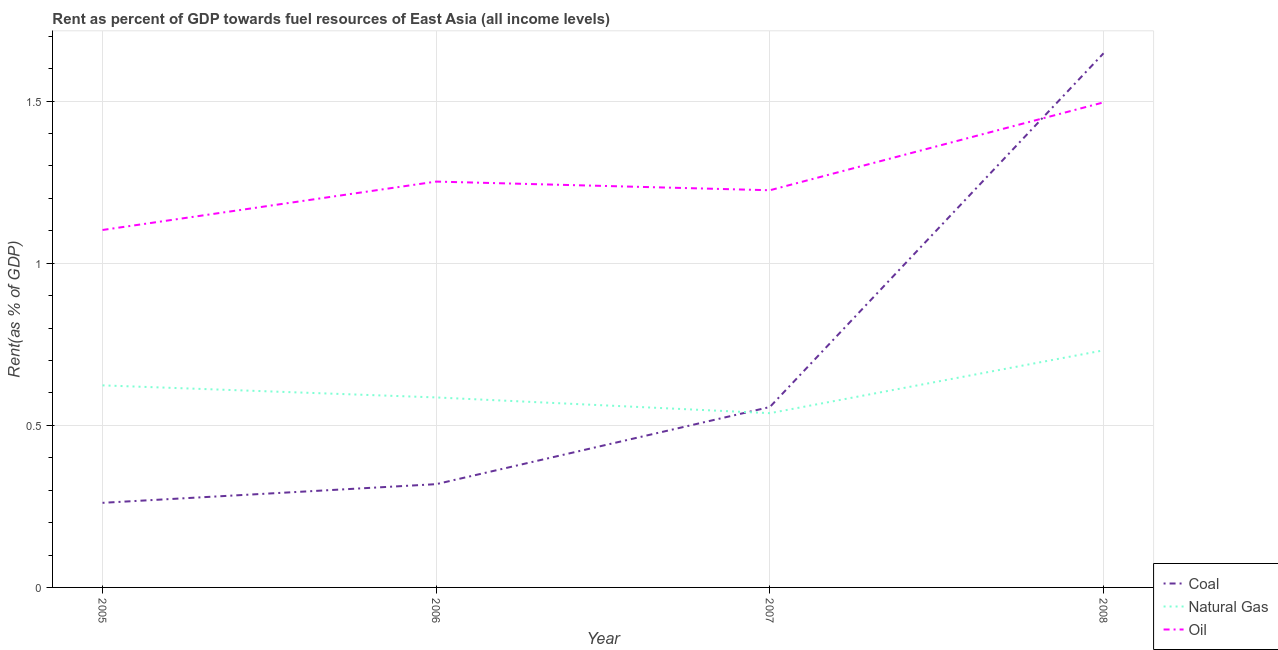How many different coloured lines are there?
Ensure brevity in your answer.  3. Does the line corresponding to rent towards coal intersect with the line corresponding to rent towards natural gas?
Your answer should be compact. Yes. Is the number of lines equal to the number of legend labels?
Offer a very short reply. Yes. What is the rent towards natural gas in 2008?
Give a very brief answer. 0.73. Across all years, what is the maximum rent towards coal?
Ensure brevity in your answer.  1.65. Across all years, what is the minimum rent towards coal?
Give a very brief answer. 0.26. In which year was the rent towards natural gas maximum?
Offer a very short reply. 2008. What is the total rent towards coal in the graph?
Your answer should be very brief. 2.78. What is the difference between the rent towards natural gas in 2005 and that in 2006?
Your response must be concise. 0.04. What is the difference between the rent towards coal in 2008 and the rent towards natural gas in 2006?
Offer a very short reply. 1.06. What is the average rent towards natural gas per year?
Ensure brevity in your answer.  0.62. In the year 2007, what is the difference between the rent towards natural gas and rent towards coal?
Keep it short and to the point. -0.02. In how many years, is the rent towards oil greater than 1.5 %?
Offer a terse response. 0. What is the ratio of the rent towards oil in 2005 to that in 2008?
Provide a succinct answer. 0.74. Is the difference between the rent towards coal in 2005 and 2008 greater than the difference between the rent towards natural gas in 2005 and 2008?
Your answer should be compact. No. What is the difference between the highest and the second highest rent towards oil?
Offer a terse response. 0.24. What is the difference between the highest and the lowest rent towards natural gas?
Ensure brevity in your answer.  0.19. In how many years, is the rent towards coal greater than the average rent towards coal taken over all years?
Ensure brevity in your answer.  1. Is the sum of the rent towards oil in 2005 and 2007 greater than the maximum rent towards coal across all years?
Keep it short and to the point. Yes. Is it the case that in every year, the sum of the rent towards coal and rent towards natural gas is greater than the rent towards oil?
Your answer should be very brief. No. Is the rent towards natural gas strictly greater than the rent towards coal over the years?
Ensure brevity in your answer.  No. Are the values on the major ticks of Y-axis written in scientific E-notation?
Offer a very short reply. No. Does the graph contain grids?
Keep it short and to the point. Yes. What is the title of the graph?
Your response must be concise. Rent as percent of GDP towards fuel resources of East Asia (all income levels). What is the label or title of the X-axis?
Ensure brevity in your answer.  Year. What is the label or title of the Y-axis?
Give a very brief answer. Rent(as % of GDP). What is the Rent(as % of GDP) of Coal in 2005?
Your response must be concise. 0.26. What is the Rent(as % of GDP) in Natural Gas in 2005?
Your answer should be very brief. 0.62. What is the Rent(as % of GDP) in Oil in 2005?
Provide a short and direct response. 1.1. What is the Rent(as % of GDP) in Coal in 2006?
Offer a terse response. 0.32. What is the Rent(as % of GDP) of Natural Gas in 2006?
Provide a succinct answer. 0.59. What is the Rent(as % of GDP) of Oil in 2006?
Provide a succinct answer. 1.25. What is the Rent(as % of GDP) in Coal in 2007?
Provide a short and direct response. 0.56. What is the Rent(as % of GDP) of Natural Gas in 2007?
Ensure brevity in your answer.  0.54. What is the Rent(as % of GDP) in Oil in 2007?
Offer a very short reply. 1.22. What is the Rent(as % of GDP) in Coal in 2008?
Provide a succinct answer. 1.65. What is the Rent(as % of GDP) of Natural Gas in 2008?
Provide a short and direct response. 0.73. What is the Rent(as % of GDP) of Oil in 2008?
Your answer should be very brief. 1.5. Across all years, what is the maximum Rent(as % of GDP) in Coal?
Offer a terse response. 1.65. Across all years, what is the maximum Rent(as % of GDP) of Natural Gas?
Keep it short and to the point. 0.73. Across all years, what is the maximum Rent(as % of GDP) of Oil?
Your answer should be very brief. 1.5. Across all years, what is the minimum Rent(as % of GDP) of Coal?
Your answer should be compact. 0.26. Across all years, what is the minimum Rent(as % of GDP) of Natural Gas?
Give a very brief answer. 0.54. Across all years, what is the minimum Rent(as % of GDP) of Oil?
Give a very brief answer. 1.1. What is the total Rent(as % of GDP) in Coal in the graph?
Ensure brevity in your answer.  2.78. What is the total Rent(as % of GDP) of Natural Gas in the graph?
Give a very brief answer. 2.48. What is the total Rent(as % of GDP) in Oil in the graph?
Give a very brief answer. 5.07. What is the difference between the Rent(as % of GDP) in Coal in 2005 and that in 2006?
Provide a short and direct response. -0.06. What is the difference between the Rent(as % of GDP) of Natural Gas in 2005 and that in 2006?
Keep it short and to the point. 0.04. What is the difference between the Rent(as % of GDP) of Oil in 2005 and that in 2006?
Provide a succinct answer. -0.15. What is the difference between the Rent(as % of GDP) in Coal in 2005 and that in 2007?
Offer a terse response. -0.3. What is the difference between the Rent(as % of GDP) of Natural Gas in 2005 and that in 2007?
Keep it short and to the point. 0.09. What is the difference between the Rent(as % of GDP) of Oil in 2005 and that in 2007?
Your answer should be compact. -0.12. What is the difference between the Rent(as % of GDP) in Coal in 2005 and that in 2008?
Your response must be concise. -1.39. What is the difference between the Rent(as % of GDP) of Natural Gas in 2005 and that in 2008?
Your answer should be very brief. -0.11. What is the difference between the Rent(as % of GDP) of Oil in 2005 and that in 2008?
Keep it short and to the point. -0.39. What is the difference between the Rent(as % of GDP) in Coal in 2006 and that in 2007?
Offer a terse response. -0.24. What is the difference between the Rent(as % of GDP) in Natural Gas in 2006 and that in 2007?
Your answer should be compact. 0.05. What is the difference between the Rent(as % of GDP) in Oil in 2006 and that in 2007?
Make the answer very short. 0.03. What is the difference between the Rent(as % of GDP) in Coal in 2006 and that in 2008?
Ensure brevity in your answer.  -1.33. What is the difference between the Rent(as % of GDP) in Natural Gas in 2006 and that in 2008?
Offer a very short reply. -0.15. What is the difference between the Rent(as % of GDP) in Oil in 2006 and that in 2008?
Your answer should be very brief. -0.24. What is the difference between the Rent(as % of GDP) of Coal in 2007 and that in 2008?
Keep it short and to the point. -1.09. What is the difference between the Rent(as % of GDP) of Natural Gas in 2007 and that in 2008?
Provide a short and direct response. -0.19. What is the difference between the Rent(as % of GDP) in Oil in 2007 and that in 2008?
Provide a succinct answer. -0.27. What is the difference between the Rent(as % of GDP) of Coal in 2005 and the Rent(as % of GDP) of Natural Gas in 2006?
Your answer should be very brief. -0.33. What is the difference between the Rent(as % of GDP) in Coal in 2005 and the Rent(as % of GDP) in Oil in 2006?
Your answer should be very brief. -0.99. What is the difference between the Rent(as % of GDP) of Natural Gas in 2005 and the Rent(as % of GDP) of Oil in 2006?
Your response must be concise. -0.63. What is the difference between the Rent(as % of GDP) in Coal in 2005 and the Rent(as % of GDP) in Natural Gas in 2007?
Ensure brevity in your answer.  -0.28. What is the difference between the Rent(as % of GDP) of Coal in 2005 and the Rent(as % of GDP) of Oil in 2007?
Provide a short and direct response. -0.96. What is the difference between the Rent(as % of GDP) of Natural Gas in 2005 and the Rent(as % of GDP) of Oil in 2007?
Keep it short and to the point. -0.6. What is the difference between the Rent(as % of GDP) in Coal in 2005 and the Rent(as % of GDP) in Natural Gas in 2008?
Your answer should be very brief. -0.47. What is the difference between the Rent(as % of GDP) of Coal in 2005 and the Rent(as % of GDP) of Oil in 2008?
Give a very brief answer. -1.24. What is the difference between the Rent(as % of GDP) of Natural Gas in 2005 and the Rent(as % of GDP) of Oil in 2008?
Your response must be concise. -0.87. What is the difference between the Rent(as % of GDP) of Coal in 2006 and the Rent(as % of GDP) of Natural Gas in 2007?
Your answer should be compact. -0.22. What is the difference between the Rent(as % of GDP) of Coal in 2006 and the Rent(as % of GDP) of Oil in 2007?
Provide a succinct answer. -0.91. What is the difference between the Rent(as % of GDP) of Natural Gas in 2006 and the Rent(as % of GDP) of Oil in 2007?
Make the answer very short. -0.64. What is the difference between the Rent(as % of GDP) in Coal in 2006 and the Rent(as % of GDP) in Natural Gas in 2008?
Provide a short and direct response. -0.41. What is the difference between the Rent(as % of GDP) of Coal in 2006 and the Rent(as % of GDP) of Oil in 2008?
Provide a succinct answer. -1.18. What is the difference between the Rent(as % of GDP) of Natural Gas in 2006 and the Rent(as % of GDP) of Oil in 2008?
Make the answer very short. -0.91. What is the difference between the Rent(as % of GDP) in Coal in 2007 and the Rent(as % of GDP) in Natural Gas in 2008?
Your response must be concise. -0.17. What is the difference between the Rent(as % of GDP) of Coal in 2007 and the Rent(as % of GDP) of Oil in 2008?
Provide a short and direct response. -0.94. What is the difference between the Rent(as % of GDP) of Natural Gas in 2007 and the Rent(as % of GDP) of Oil in 2008?
Keep it short and to the point. -0.96. What is the average Rent(as % of GDP) of Coal per year?
Give a very brief answer. 0.7. What is the average Rent(as % of GDP) of Natural Gas per year?
Keep it short and to the point. 0.62. What is the average Rent(as % of GDP) in Oil per year?
Keep it short and to the point. 1.27. In the year 2005, what is the difference between the Rent(as % of GDP) in Coal and Rent(as % of GDP) in Natural Gas?
Offer a very short reply. -0.36. In the year 2005, what is the difference between the Rent(as % of GDP) in Coal and Rent(as % of GDP) in Oil?
Keep it short and to the point. -0.84. In the year 2005, what is the difference between the Rent(as % of GDP) of Natural Gas and Rent(as % of GDP) of Oil?
Give a very brief answer. -0.48. In the year 2006, what is the difference between the Rent(as % of GDP) of Coal and Rent(as % of GDP) of Natural Gas?
Your answer should be compact. -0.27. In the year 2006, what is the difference between the Rent(as % of GDP) in Coal and Rent(as % of GDP) in Oil?
Provide a short and direct response. -0.93. In the year 2006, what is the difference between the Rent(as % of GDP) of Natural Gas and Rent(as % of GDP) of Oil?
Your response must be concise. -0.67. In the year 2007, what is the difference between the Rent(as % of GDP) of Coal and Rent(as % of GDP) of Natural Gas?
Offer a terse response. 0.02. In the year 2007, what is the difference between the Rent(as % of GDP) of Coal and Rent(as % of GDP) of Oil?
Your answer should be very brief. -0.67. In the year 2007, what is the difference between the Rent(as % of GDP) of Natural Gas and Rent(as % of GDP) of Oil?
Provide a succinct answer. -0.69. In the year 2008, what is the difference between the Rent(as % of GDP) in Coal and Rent(as % of GDP) in Natural Gas?
Make the answer very short. 0.92. In the year 2008, what is the difference between the Rent(as % of GDP) in Coal and Rent(as % of GDP) in Oil?
Make the answer very short. 0.15. In the year 2008, what is the difference between the Rent(as % of GDP) in Natural Gas and Rent(as % of GDP) in Oil?
Ensure brevity in your answer.  -0.76. What is the ratio of the Rent(as % of GDP) of Coal in 2005 to that in 2006?
Offer a very short reply. 0.82. What is the ratio of the Rent(as % of GDP) in Natural Gas in 2005 to that in 2006?
Your answer should be compact. 1.06. What is the ratio of the Rent(as % of GDP) of Oil in 2005 to that in 2006?
Ensure brevity in your answer.  0.88. What is the ratio of the Rent(as % of GDP) of Coal in 2005 to that in 2007?
Offer a very short reply. 0.47. What is the ratio of the Rent(as % of GDP) in Natural Gas in 2005 to that in 2007?
Offer a terse response. 1.16. What is the ratio of the Rent(as % of GDP) in Coal in 2005 to that in 2008?
Your response must be concise. 0.16. What is the ratio of the Rent(as % of GDP) of Natural Gas in 2005 to that in 2008?
Make the answer very short. 0.85. What is the ratio of the Rent(as % of GDP) of Oil in 2005 to that in 2008?
Provide a succinct answer. 0.74. What is the ratio of the Rent(as % of GDP) of Coal in 2006 to that in 2007?
Give a very brief answer. 0.57. What is the ratio of the Rent(as % of GDP) in Natural Gas in 2006 to that in 2007?
Offer a very short reply. 1.09. What is the ratio of the Rent(as % of GDP) of Oil in 2006 to that in 2007?
Give a very brief answer. 1.02. What is the ratio of the Rent(as % of GDP) in Coal in 2006 to that in 2008?
Offer a terse response. 0.19. What is the ratio of the Rent(as % of GDP) in Natural Gas in 2006 to that in 2008?
Your response must be concise. 0.8. What is the ratio of the Rent(as % of GDP) in Oil in 2006 to that in 2008?
Ensure brevity in your answer.  0.84. What is the ratio of the Rent(as % of GDP) of Coal in 2007 to that in 2008?
Give a very brief answer. 0.34. What is the ratio of the Rent(as % of GDP) of Natural Gas in 2007 to that in 2008?
Your answer should be very brief. 0.73. What is the ratio of the Rent(as % of GDP) in Oil in 2007 to that in 2008?
Give a very brief answer. 0.82. What is the difference between the highest and the second highest Rent(as % of GDP) of Coal?
Provide a short and direct response. 1.09. What is the difference between the highest and the second highest Rent(as % of GDP) of Natural Gas?
Keep it short and to the point. 0.11. What is the difference between the highest and the second highest Rent(as % of GDP) in Oil?
Keep it short and to the point. 0.24. What is the difference between the highest and the lowest Rent(as % of GDP) of Coal?
Your answer should be compact. 1.39. What is the difference between the highest and the lowest Rent(as % of GDP) of Natural Gas?
Your response must be concise. 0.19. What is the difference between the highest and the lowest Rent(as % of GDP) in Oil?
Give a very brief answer. 0.39. 